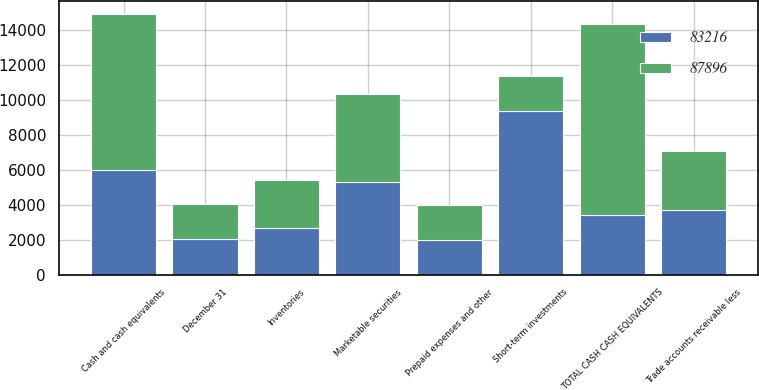Convert chart to OTSL. <chart><loc_0><loc_0><loc_500><loc_500><stacked_bar_chart><ecel><fcel>December 31<fcel>Cash and cash equivalents<fcel>Short-term investments<fcel>TOTAL CASH CASH EQUIVALENTS<fcel>Marketable securities<fcel>Trade accounts receivable less<fcel>Inventories<fcel>Prepaid expenses and other<nl><fcel>87896<fcel>2018<fcel>8926<fcel>2025<fcel>10951<fcel>5013<fcel>3396<fcel>2766<fcel>1962<nl><fcel>83216<fcel>2017<fcel>6006<fcel>9352<fcel>3396<fcel>5317<fcel>3667<fcel>2655<fcel>2000<nl></chart> 